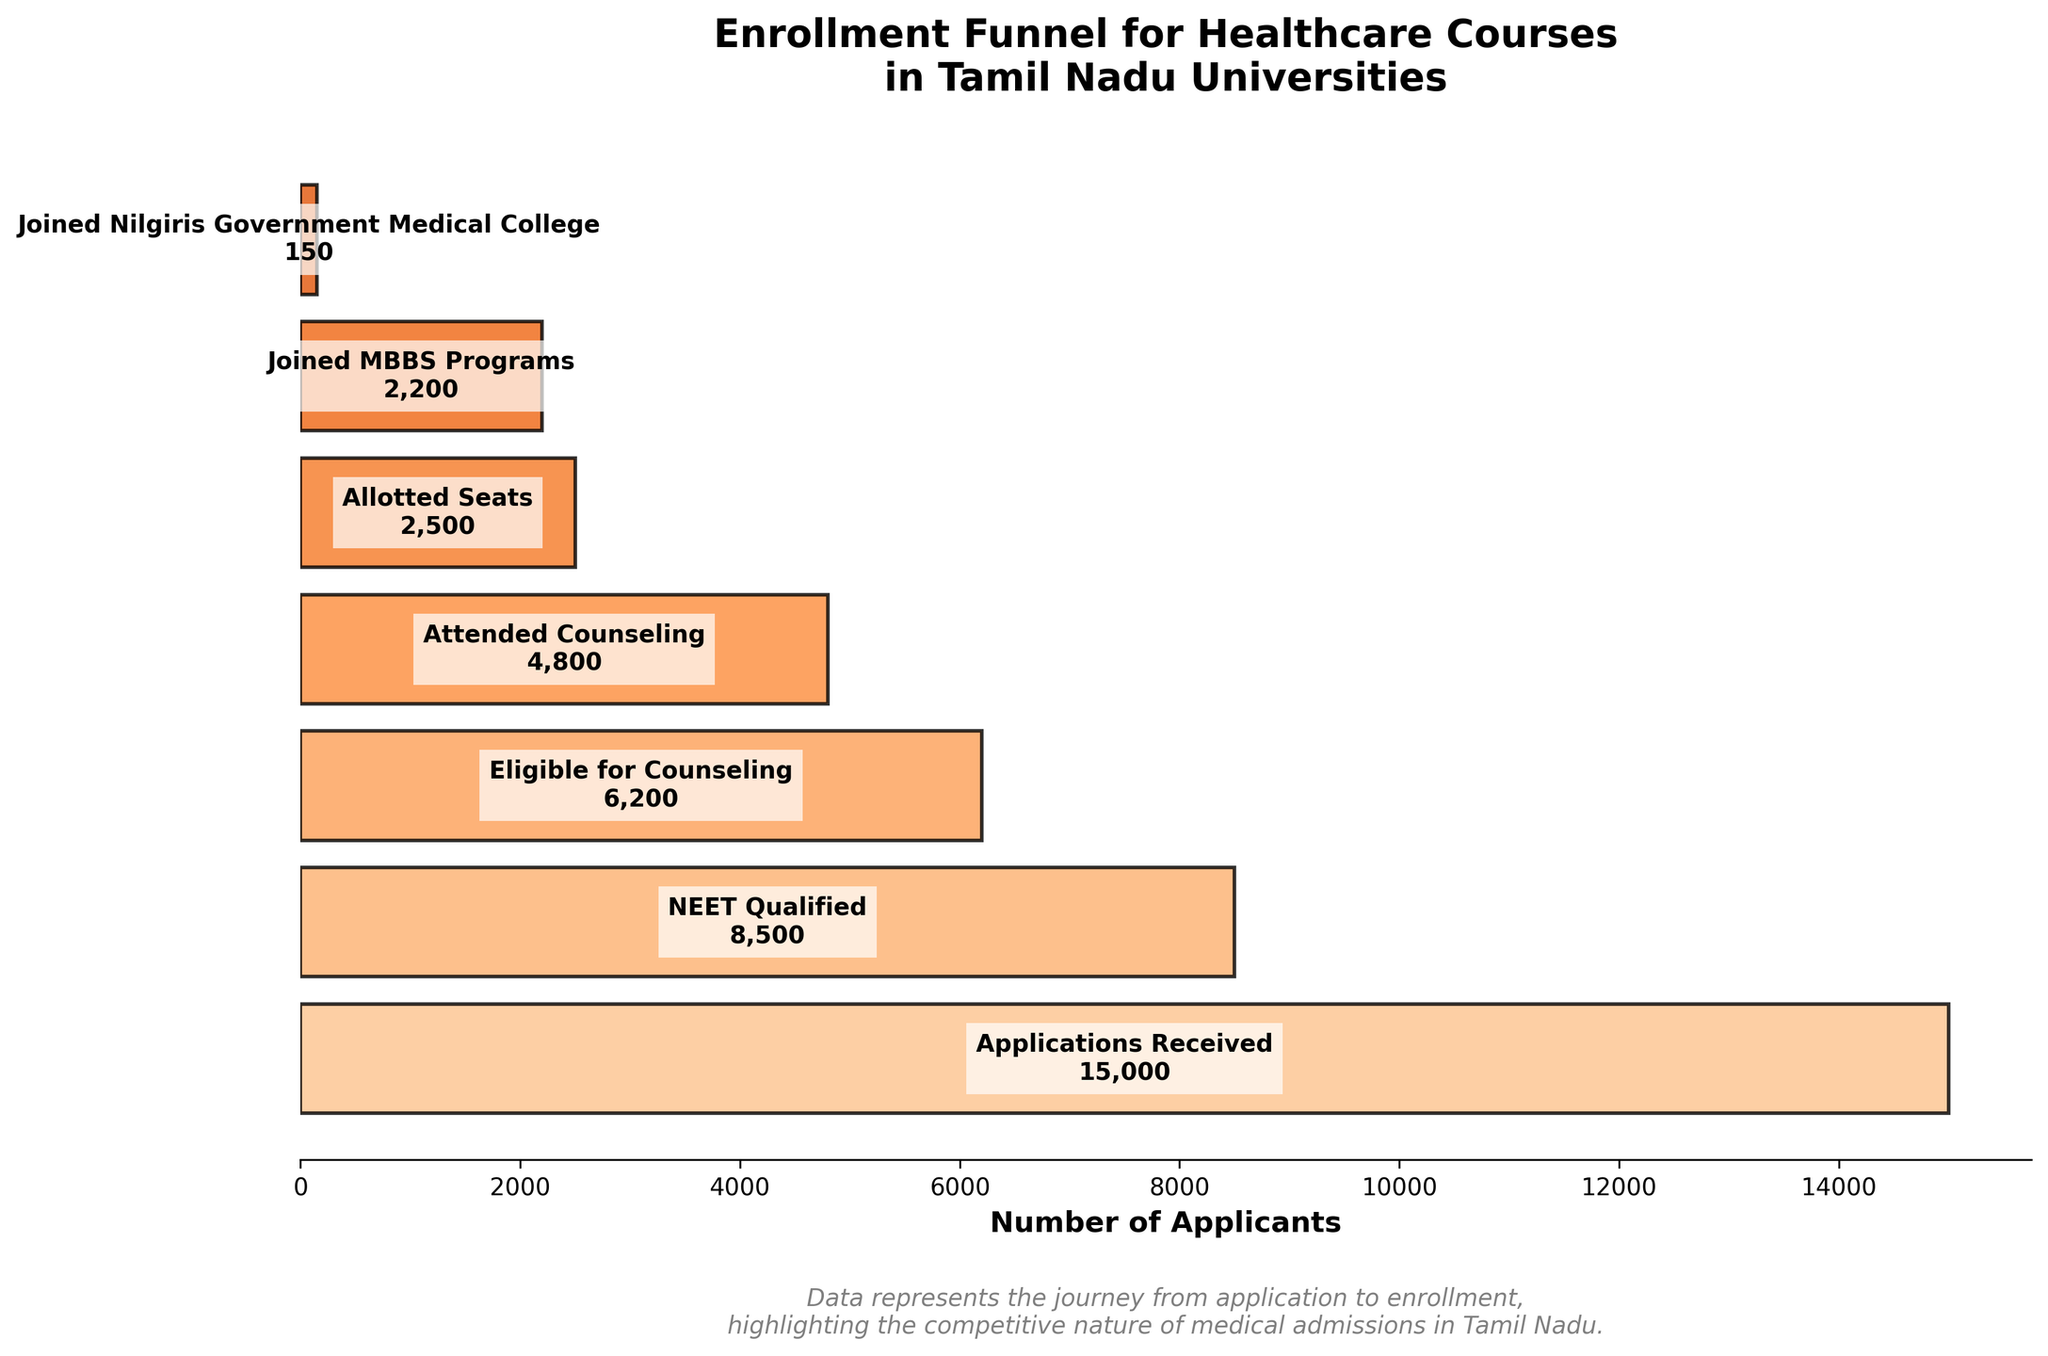How many applicants received applications for healthcare courses in Tamil Nadu universities? The figure lists the first stage as "Applications Received" with the number of applicants noted.
Answer: 15,000 What is the title of the funnel chart? The title is located at the top of the figure and describes the overall content.
Answer: Enrollment Funnel for Healthcare Courses in Tamil Nadu Universities How many applicants qualified for NEET? The "NEET Qualified" stage in the funnel lists the number of applicants who passed NEET.
Answer: 8,500 How many candidates joined the Nilgiris Government Medical College? The final stage "Joined Nilgiris Government Medical College" indicates the number of applicants.
Answer: 150 How many applicants joined MBBS Programs? The “Joined MBBS Programs” stage shows the number of applicants who enrolled in these programs.
Answer: 2,200 